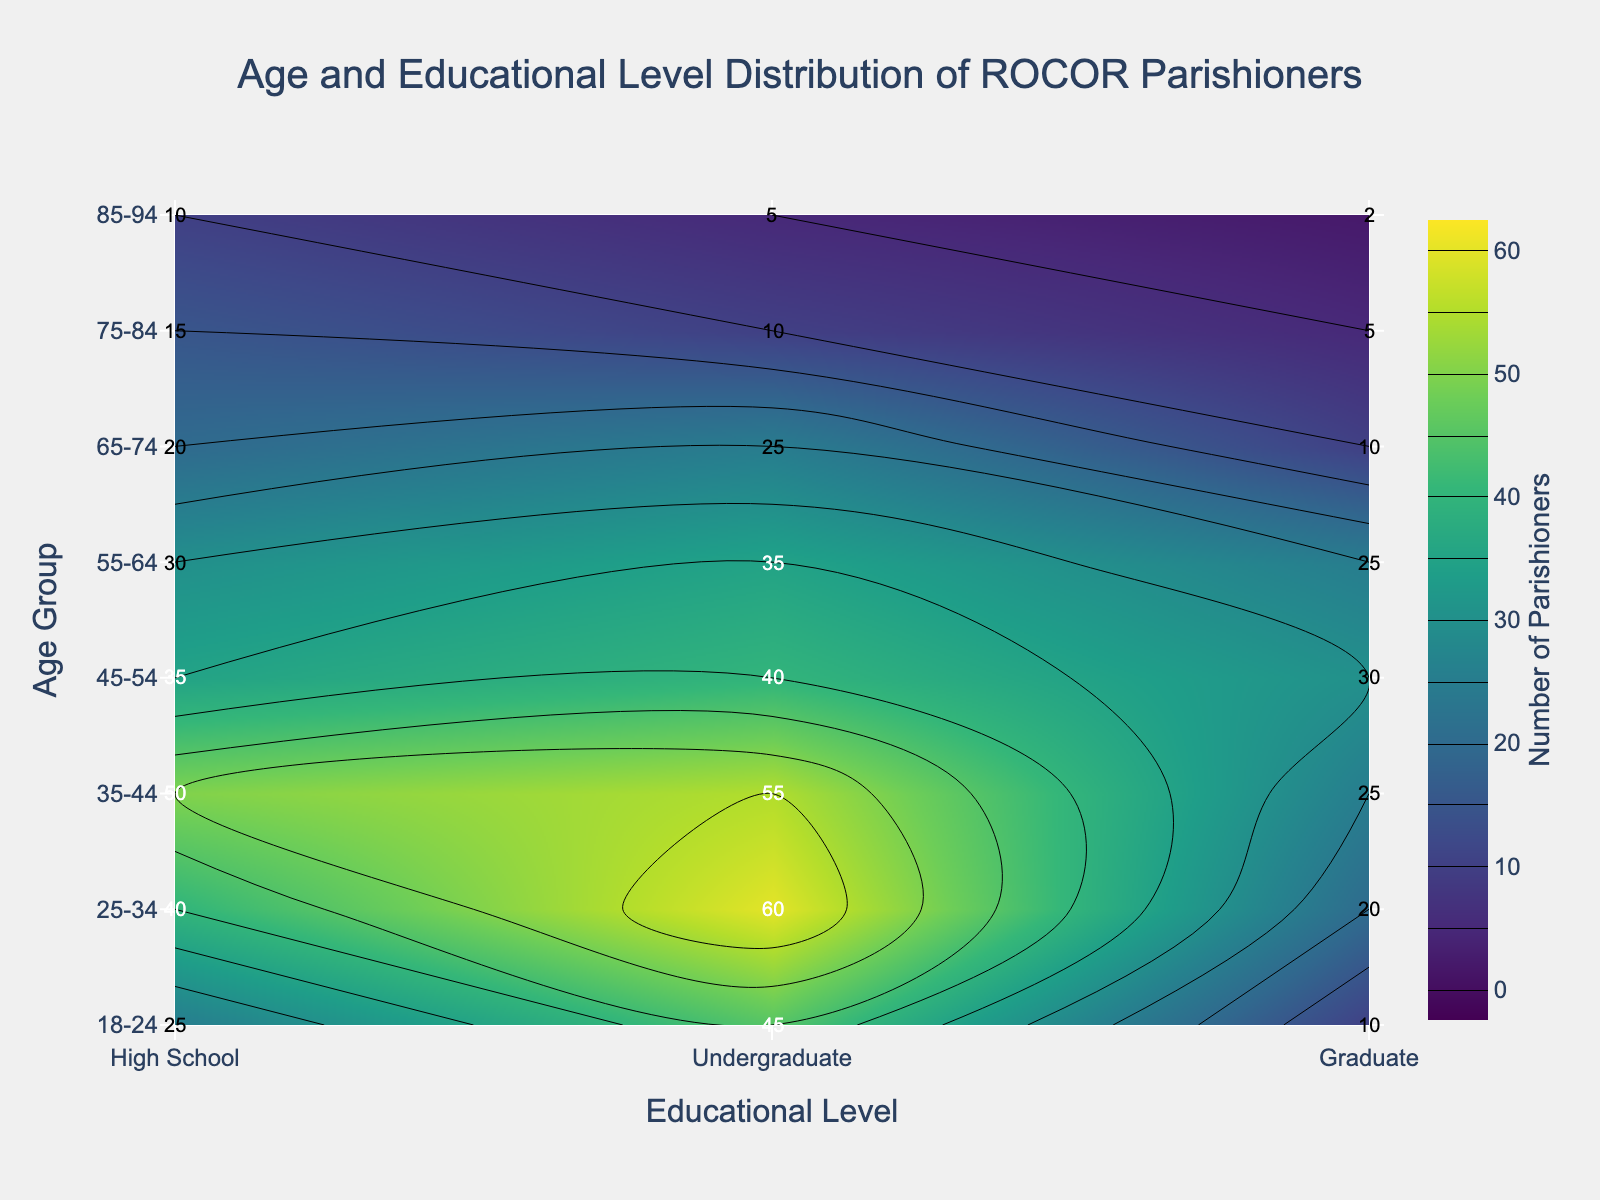What is the title of the figure? The title of the figure is usually displayed prominently at the top. In this case, the title is "Age and Educational Level Distribution of ROCOR Parishioners," indicating what the figure represents.
Answer: Age and Educational Level Distribution of ROCOR Parishioners What are the axis titles on the figure? The axis titles can be found along the axes. The x-axis title is 'Educational Level,' and the y-axis title is 'Age Group,' indicating the dimensions represented by each axis.
Answer: Educational Level (x-axis), Age Group (y-axis) Which age group has the highest number of parishioners with an undergraduate educational level? To find the age group with the highest number of parishioners with an undergraduate level, look for the highest value in the 'Undergraduate' column. In this case, the age group '25-34' has the highest number with 60 parishioners.
Answer: 25-34 What is the count of parishioners aged 45-54 with a high school educational level? Locate the cell that corresponds to the age group '45-54' in the 'High School' column. The number of parishioners in this group is 35.
Answer: 35 How does the number of parishioners with a graduate level change from the 35-44 age group to the 45-54 age group? Compare the figures in the 'Graduate' row for the age groups '35-44' and '45-54'. The number decreases from 25 (35-44) to 30 (45-54).
Answer: Increases by 5 Which age group and educational level combination represents the highest number of parishioners overall in the plot? Scan through all the values in the heatmap. The highest value is found at the intersection of the 'Undergraduate' level and '25-34' age group which has 60 parishioners.
Answer: 25-34, Undergraduate What is the total number of parishioners within the 18-24 age group? Sum up the values for all educational levels within the '18-24' age group: 25 (High School) + 45 (Undergraduate) + 10 (Graduate) = 80.
Answer: 80 Which educational level has the fewest parishioners aged 85-94? Compare the values for the '85-94' age group across different educational levels. The fewest parishioners are in the 'Graduate' level, with 2 parishioners.
Answer: Graduate Is there an age group where the number of undergraduate parishioners is less than the number of high school parishioners? Compare the numbers across age groups for 'Undergraduate' and 'High School' levels. In the age group '75-84', there are 10 (Undergraduate) which is less than 15 (High School).
Answer: Yes, in the 75-84 age group What is the average number of parishioners aged 55-64 across all educational levels? Sum the parishioners in the '55-64' group and divide by the number of educational levels. (30 + 35 + 25) / 3 = 90 / 3 = 30.
Answer: 30 